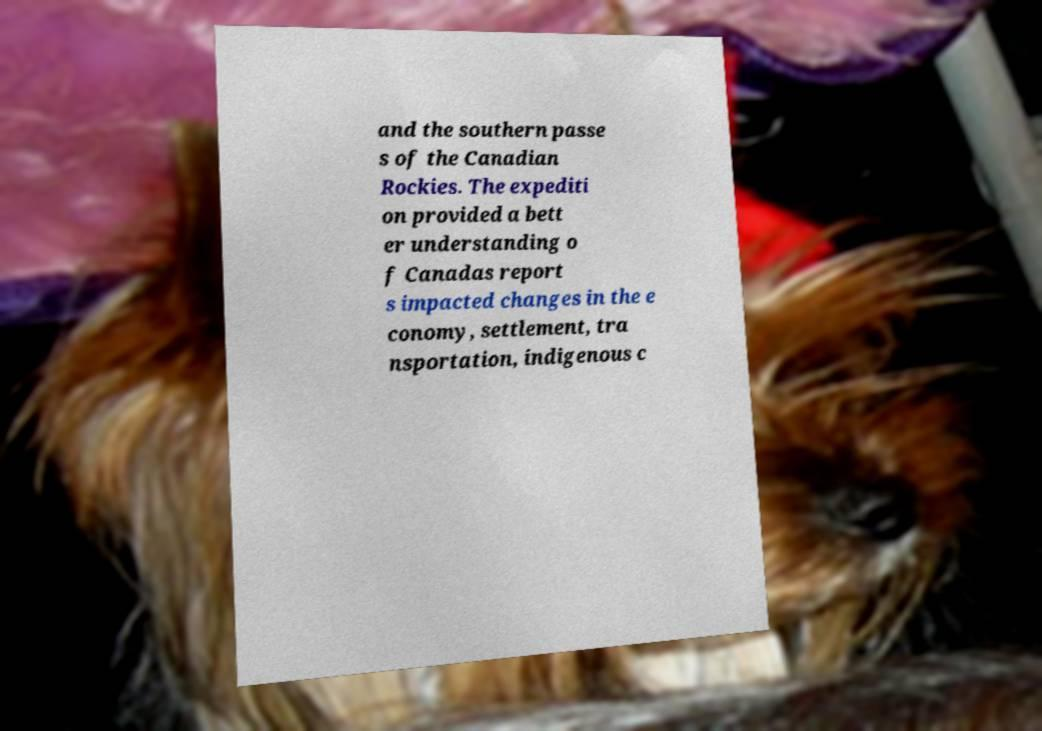There's text embedded in this image that I need extracted. Can you transcribe it verbatim? and the southern passe s of the Canadian Rockies. The expediti on provided a bett er understanding o f Canadas report s impacted changes in the e conomy, settlement, tra nsportation, indigenous c 